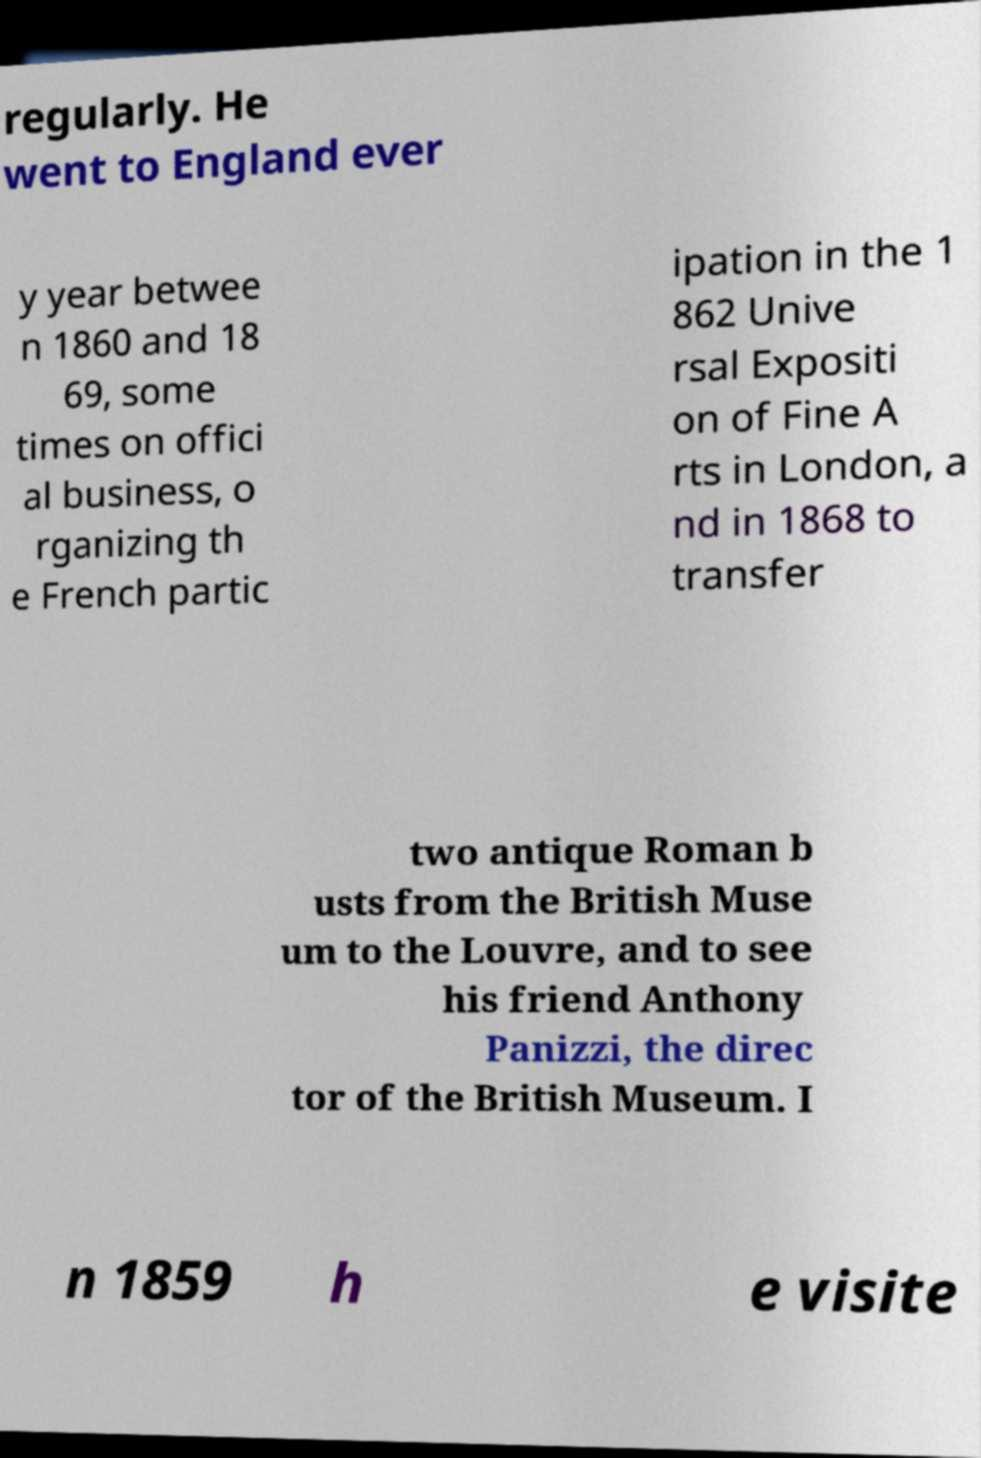For documentation purposes, I need the text within this image transcribed. Could you provide that? regularly. He went to England ever y year betwee n 1860 and 18 69, some times on offici al business, o rganizing th e French partic ipation in the 1 862 Unive rsal Expositi on of Fine A rts in London, a nd in 1868 to transfer two antique Roman b usts from the British Muse um to the Louvre, and to see his friend Anthony Panizzi, the direc tor of the British Museum. I n 1859 h e visite 